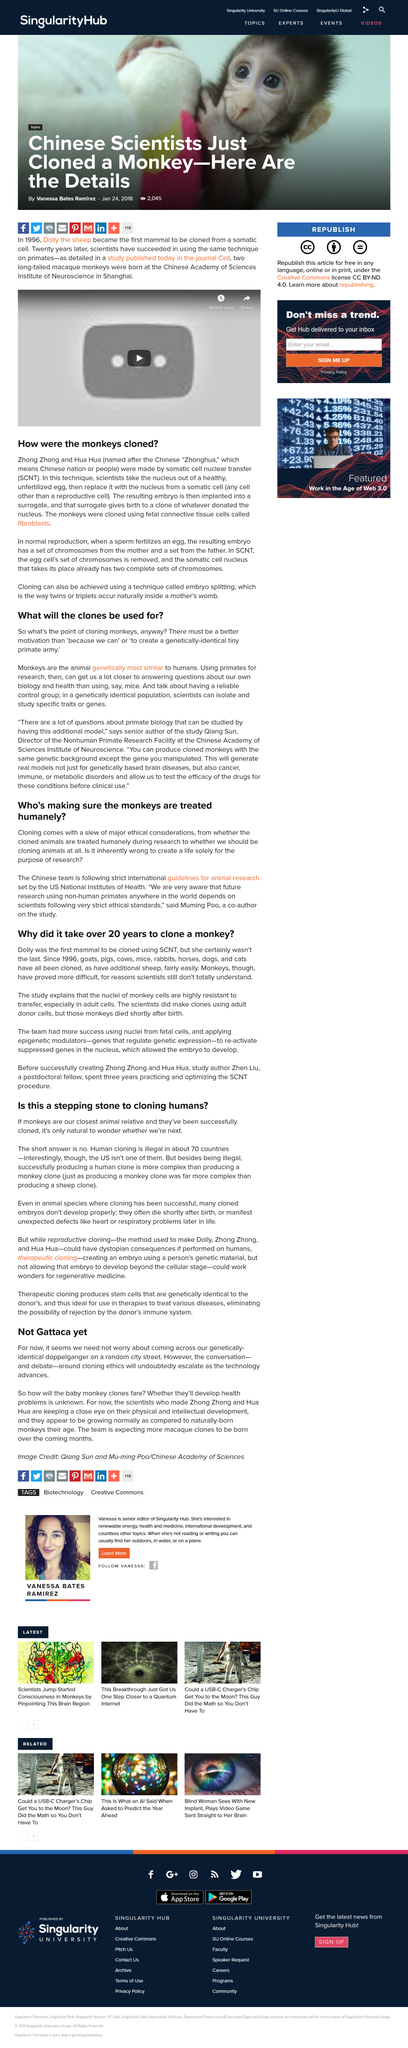Outline some significant characteristics in this image. The scientists who made Zhong Zhong and Hua Hua are observing their physical and intellectual development. Fibroblasts from fetal monkey connective tissue were used to clone the monkeys. The somatic cell nucleus contains two complete sets of chromosomes. The international guidelines for animal research are set by the US National Institutes of Health. The scientific methodology being discussed is cloning. 